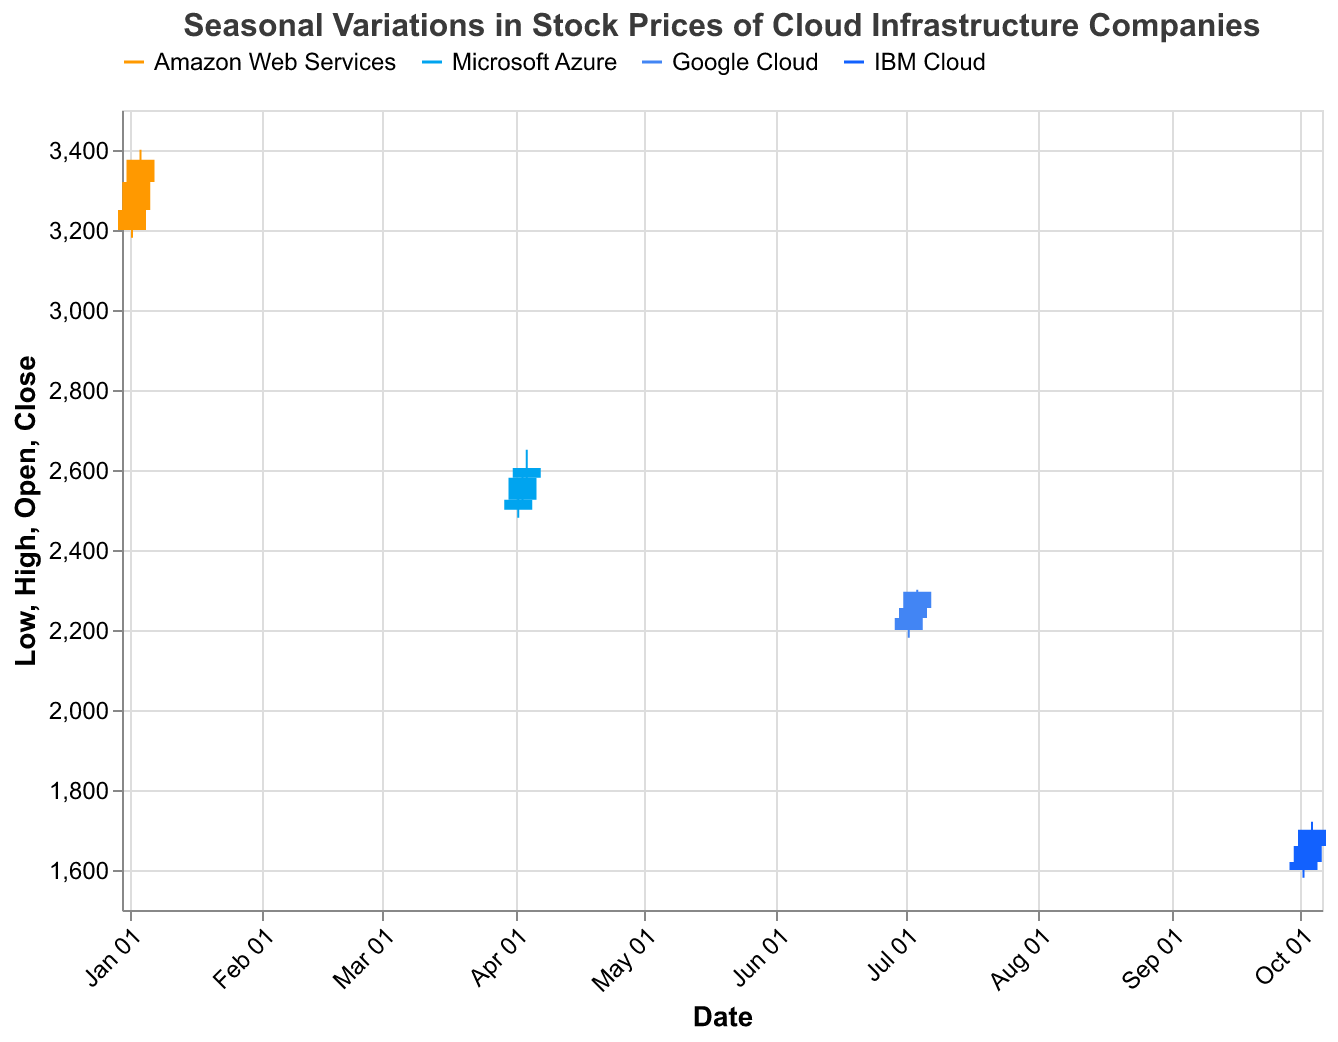What is the title of the figure? The title is placed at the top of the chart and summarizes what the chart is about. The textual description says: "Seasonal Variations in Stock Prices of Cloud Infrastructure Companies".
Answer: Seasonal Variations in Stock Prices of Cloud Infrastructure Companies What are the four companies represented in the plot? The legend at the top of the plot lists the companies represented by different colors. They are Amazon Web Services, Microsoft Azure, Google Cloud, and IBM Cloud.
Answer: Amazon Web Services, Microsoft Azure, Google Cloud, IBM Cloud Which stock had the highest closing price and what was it? By examining the highest positions on the closing price bars for each stock, Amazon Web Services on January 4th had the highest closing price at 3375.44.
Answer: Amazon Web Services, 3375.44 How did the stock price of Microsoft Azure change between April 2nd and April 4th? Looking at the opening and closing prices for these dates: On April 2nd (Open: 2500.50, Close: 2525.80), and on April 4th (Open: 2580.32, Close: 2605.01), the stock price increased consistently.
Answer: Increased What is the date range shown in the plot? The x-axis begins on January 2nd and ends on October 4th, covering different dates for the four companies. This can be noted from the progression from "Jan" to "Oct" across the x-axis labels.
Answer: January 2nd to October 4th How does Google's stock volume on July 2nd compare to its volume on July 4th? The plot includes volume in the tooltip, showing that Google's volume on July 2nd was 2800000, while on July 4th, it was 2900000. Comparing these volumes shows an increase.
Answer: Increased from 2800000 to 2900000 Which company had the lowest recorded price, and what was it? IBM Cloud on October 2nd had a Low of 1580.76, noted from the lowest section of the candlestick. This is the lowest recorded price among all companies.
Answer: IBM Cloud, 1580.76 Which company had the least volatility on January 3rd? Volatility can be inferred from the range between high and low prices. Amazon Web Services had a high of 3350.22 and a low of 3225.50 on January 3rd, resulting in a difference of 124.72. No other company is recorded for this date.
Answer: Amazon Web Services Compare the opening price of Amazon Web Services on January 2nd and January 4th. On January 2nd, the opening price was 3200.15. On January 4th, it was 3320.18. The increase can be calculated by subtracting the earlier from the latter (3320.18 - 3200.15).
Answer: 120.03 higher on January 4th What pattern do you observe in the closing prices for Amazon Web Services from January 2nd to January 4th? By reviewing the closing prices sequentially: January 2nd: 3250.19, January 3rd: 3320.18, January 4th: 3375.44, we observe a consistent increase each day.
Answer: Consistent increase 